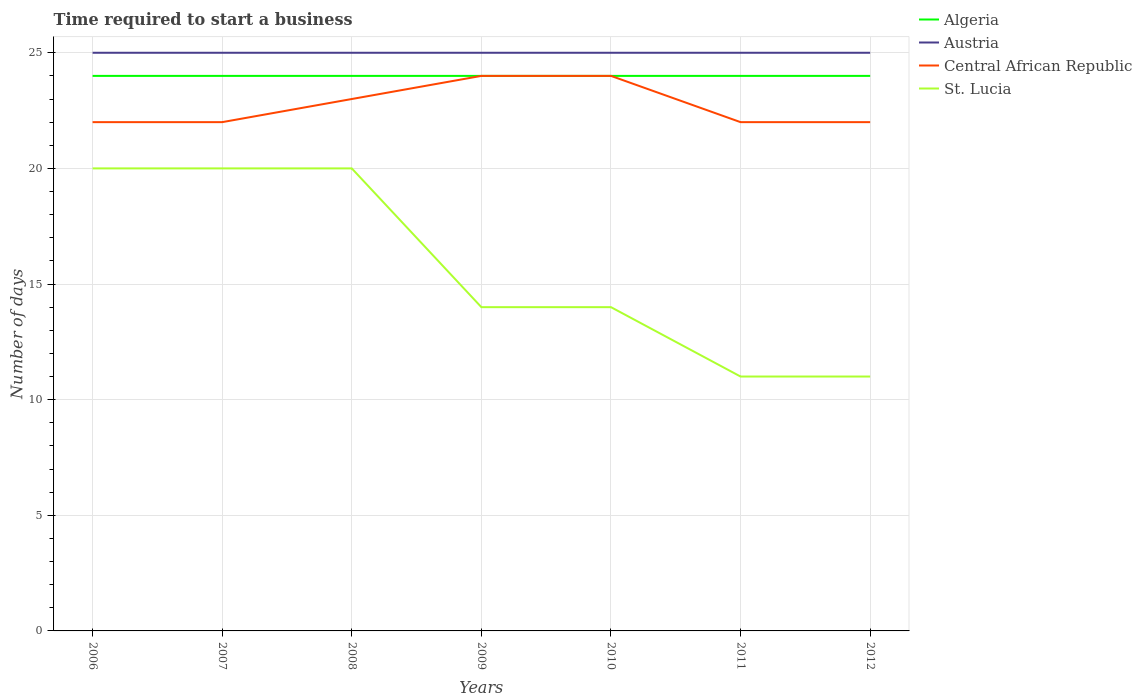How many different coloured lines are there?
Your response must be concise. 4. Does the line corresponding to Algeria intersect with the line corresponding to Central African Republic?
Your answer should be very brief. Yes. Is the number of lines equal to the number of legend labels?
Offer a very short reply. Yes. Across all years, what is the maximum number of days required to start a business in Central African Republic?
Make the answer very short. 22. In which year was the number of days required to start a business in Austria maximum?
Ensure brevity in your answer.  2006. What is the difference between the highest and the lowest number of days required to start a business in Austria?
Give a very brief answer. 0. Is the number of days required to start a business in Central African Republic strictly greater than the number of days required to start a business in Algeria over the years?
Your answer should be compact. No. How many lines are there?
Offer a very short reply. 4. Are the values on the major ticks of Y-axis written in scientific E-notation?
Provide a short and direct response. No. Does the graph contain any zero values?
Offer a very short reply. No. Does the graph contain grids?
Your response must be concise. Yes. Where does the legend appear in the graph?
Offer a terse response. Top right. How are the legend labels stacked?
Make the answer very short. Vertical. What is the title of the graph?
Provide a short and direct response. Time required to start a business. Does "Turkey" appear as one of the legend labels in the graph?
Your answer should be compact. No. What is the label or title of the Y-axis?
Make the answer very short. Number of days. What is the Number of days in Austria in 2006?
Offer a very short reply. 25. What is the Number of days in Austria in 2007?
Keep it short and to the point. 25. What is the Number of days in St. Lucia in 2007?
Keep it short and to the point. 20. What is the Number of days in Austria in 2008?
Ensure brevity in your answer.  25. What is the Number of days in Central African Republic in 2008?
Your response must be concise. 23. What is the Number of days of Algeria in 2009?
Keep it short and to the point. 24. What is the Number of days of Austria in 2009?
Offer a terse response. 25. What is the Number of days in Central African Republic in 2009?
Give a very brief answer. 24. What is the Number of days of Algeria in 2010?
Provide a succinct answer. 24. What is the Number of days of Austria in 2010?
Give a very brief answer. 25. What is the Number of days of St. Lucia in 2010?
Give a very brief answer. 14. What is the Number of days in Austria in 2011?
Offer a terse response. 25. What is the Number of days of Algeria in 2012?
Make the answer very short. 24. What is the Number of days in Central African Republic in 2012?
Give a very brief answer. 22. Across all years, what is the maximum Number of days of Algeria?
Provide a short and direct response. 24. Across all years, what is the maximum Number of days in Central African Republic?
Make the answer very short. 24. Across all years, what is the maximum Number of days in St. Lucia?
Keep it short and to the point. 20. Across all years, what is the minimum Number of days of Algeria?
Your answer should be very brief. 24. Across all years, what is the minimum Number of days in St. Lucia?
Your answer should be very brief. 11. What is the total Number of days of Algeria in the graph?
Your answer should be very brief. 168. What is the total Number of days in Austria in the graph?
Give a very brief answer. 175. What is the total Number of days in Central African Republic in the graph?
Your answer should be very brief. 159. What is the total Number of days of St. Lucia in the graph?
Your answer should be very brief. 110. What is the difference between the Number of days in Algeria in 2006 and that in 2007?
Give a very brief answer. 0. What is the difference between the Number of days of Central African Republic in 2006 and that in 2008?
Keep it short and to the point. -1. What is the difference between the Number of days of St. Lucia in 2006 and that in 2008?
Offer a very short reply. 0. What is the difference between the Number of days in Algeria in 2006 and that in 2009?
Provide a short and direct response. 0. What is the difference between the Number of days of St. Lucia in 2006 and that in 2009?
Offer a terse response. 6. What is the difference between the Number of days of Algeria in 2006 and that in 2010?
Offer a terse response. 0. What is the difference between the Number of days of Central African Republic in 2006 and that in 2010?
Keep it short and to the point. -2. What is the difference between the Number of days of Algeria in 2006 and that in 2011?
Your response must be concise. 0. What is the difference between the Number of days in Austria in 2006 and that in 2011?
Make the answer very short. 0. What is the difference between the Number of days in Central African Republic in 2006 and that in 2011?
Your response must be concise. 0. What is the difference between the Number of days in St. Lucia in 2006 and that in 2011?
Make the answer very short. 9. What is the difference between the Number of days of Algeria in 2006 and that in 2012?
Ensure brevity in your answer.  0. What is the difference between the Number of days in Central African Republic in 2006 and that in 2012?
Offer a terse response. 0. What is the difference between the Number of days in Algeria in 2007 and that in 2008?
Offer a very short reply. 0. What is the difference between the Number of days of Algeria in 2007 and that in 2009?
Give a very brief answer. 0. What is the difference between the Number of days of Central African Republic in 2007 and that in 2009?
Ensure brevity in your answer.  -2. What is the difference between the Number of days in Austria in 2007 and that in 2010?
Make the answer very short. 0. What is the difference between the Number of days in St. Lucia in 2007 and that in 2010?
Give a very brief answer. 6. What is the difference between the Number of days in Austria in 2007 and that in 2011?
Provide a succinct answer. 0. What is the difference between the Number of days of St. Lucia in 2007 and that in 2011?
Provide a short and direct response. 9. What is the difference between the Number of days in Austria in 2007 and that in 2012?
Make the answer very short. 0. What is the difference between the Number of days in Central African Republic in 2007 and that in 2012?
Provide a short and direct response. 0. What is the difference between the Number of days in Algeria in 2008 and that in 2009?
Offer a very short reply. 0. What is the difference between the Number of days in Austria in 2008 and that in 2010?
Give a very brief answer. 0. What is the difference between the Number of days of Central African Republic in 2008 and that in 2010?
Give a very brief answer. -1. What is the difference between the Number of days in Algeria in 2008 and that in 2011?
Keep it short and to the point. 0. What is the difference between the Number of days in Austria in 2008 and that in 2011?
Ensure brevity in your answer.  0. What is the difference between the Number of days of Central African Republic in 2008 and that in 2011?
Your answer should be compact. 1. What is the difference between the Number of days of St. Lucia in 2008 and that in 2011?
Make the answer very short. 9. What is the difference between the Number of days of Algeria in 2008 and that in 2012?
Your answer should be very brief. 0. What is the difference between the Number of days in Austria in 2008 and that in 2012?
Your answer should be compact. 0. What is the difference between the Number of days in Central African Republic in 2008 and that in 2012?
Ensure brevity in your answer.  1. What is the difference between the Number of days of St. Lucia in 2008 and that in 2012?
Make the answer very short. 9. What is the difference between the Number of days in Algeria in 2009 and that in 2010?
Keep it short and to the point. 0. What is the difference between the Number of days of Central African Republic in 2009 and that in 2010?
Ensure brevity in your answer.  0. What is the difference between the Number of days in St. Lucia in 2009 and that in 2010?
Offer a very short reply. 0. What is the difference between the Number of days in Algeria in 2009 and that in 2011?
Provide a succinct answer. 0. What is the difference between the Number of days in St. Lucia in 2009 and that in 2011?
Provide a succinct answer. 3. What is the difference between the Number of days of Austria in 2009 and that in 2012?
Provide a short and direct response. 0. What is the difference between the Number of days of St. Lucia in 2009 and that in 2012?
Offer a very short reply. 3. What is the difference between the Number of days of Austria in 2010 and that in 2011?
Your response must be concise. 0. What is the difference between the Number of days of St. Lucia in 2010 and that in 2011?
Provide a short and direct response. 3. What is the difference between the Number of days of Central African Republic in 2010 and that in 2012?
Offer a terse response. 2. What is the difference between the Number of days of Central African Republic in 2011 and that in 2012?
Your answer should be compact. 0. What is the difference between the Number of days of Algeria in 2006 and the Number of days of Austria in 2007?
Your response must be concise. -1. What is the difference between the Number of days of Algeria in 2006 and the Number of days of St. Lucia in 2007?
Offer a terse response. 4. What is the difference between the Number of days of Austria in 2006 and the Number of days of Central African Republic in 2007?
Keep it short and to the point. 3. What is the difference between the Number of days of Central African Republic in 2006 and the Number of days of St. Lucia in 2008?
Give a very brief answer. 2. What is the difference between the Number of days of Algeria in 2006 and the Number of days of Austria in 2009?
Keep it short and to the point. -1. What is the difference between the Number of days of Algeria in 2006 and the Number of days of Central African Republic in 2009?
Make the answer very short. 0. What is the difference between the Number of days of Algeria in 2006 and the Number of days of St. Lucia in 2009?
Give a very brief answer. 10. What is the difference between the Number of days of Austria in 2006 and the Number of days of St. Lucia in 2009?
Offer a terse response. 11. What is the difference between the Number of days of Algeria in 2006 and the Number of days of Austria in 2010?
Offer a very short reply. -1. What is the difference between the Number of days of Algeria in 2006 and the Number of days of St. Lucia in 2010?
Your answer should be very brief. 10. What is the difference between the Number of days of Algeria in 2006 and the Number of days of Austria in 2011?
Give a very brief answer. -1. What is the difference between the Number of days of Austria in 2006 and the Number of days of Central African Republic in 2011?
Give a very brief answer. 3. What is the difference between the Number of days in Algeria in 2006 and the Number of days in Central African Republic in 2012?
Make the answer very short. 2. What is the difference between the Number of days in Algeria in 2006 and the Number of days in St. Lucia in 2012?
Ensure brevity in your answer.  13. What is the difference between the Number of days of Austria in 2006 and the Number of days of Central African Republic in 2012?
Provide a succinct answer. 3. What is the difference between the Number of days in Austria in 2006 and the Number of days in St. Lucia in 2012?
Keep it short and to the point. 14. What is the difference between the Number of days of Central African Republic in 2006 and the Number of days of St. Lucia in 2012?
Offer a terse response. 11. What is the difference between the Number of days of Algeria in 2007 and the Number of days of Central African Republic in 2008?
Keep it short and to the point. 1. What is the difference between the Number of days of Algeria in 2007 and the Number of days of St. Lucia in 2008?
Make the answer very short. 4. What is the difference between the Number of days in Austria in 2007 and the Number of days in St. Lucia in 2008?
Keep it short and to the point. 5. What is the difference between the Number of days in Central African Republic in 2007 and the Number of days in St. Lucia in 2008?
Offer a very short reply. 2. What is the difference between the Number of days of Algeria in 2007 and the Number of days of Austria in 2009?
Provide a short and direct response. -1. What is the difference between the Number of days of Algeria in 2007 and the Number of days of St. Lucia in 2009?
Give a very brief answer. 10. What is the difference between the Number of days of Austria in 2007 and the Number of days of St. Lucia in 2009?
Provide a short and direct response. 11. What is the difference between the Number of days in Central African Republic in 2007 and the Number of days in St. Lucia in 2009?
Your answer should be very brief. 8. What is the difference between the Number of days in Algeria in 2007 and the Number of days in Austria in 2010?
Provide a short and direct response. -1. What is the difference between the Number of days in Algeria in 2007 and the Number of days in St. Lucia in 2010?
Your answer should be very brief. 10. What is the difference between the Number of days in Austria in 2007 and the Number of days in Central African Republic in 2010?
Keep it short and to the point. 1. What is the difference between the Number of days in Austria in 2007 and the Number of days in St. Lucia in 2010?
Your answer should be very brief. 11. What is the difference between the Number of days of Central African Republic in 2007 and the Number of days of St. Lucia in 2010?
Give a very brief answer. 8. What is the difference between the Number of days of Algeria in 2007 and the Number of days of Austria in 2011?
Your answer should be very brief. -1. What is the difference between the Number of days in Algeria in 2007 and the Number of days in Central African Republic in 2011?
Your answer should be compact. 2. What is the difference between the Number of days of Austria in 2007 and the Number of days of Central African Republic in 2011?
Give a very brief answer. 3. What is the difference between the Number of days in Austria in 2007 and the Number of days in St. Lucia in 2012?
Offer a very short reply. 14. What is the difference between the Number of days of Algeria in 2008 and the Number of days of Central African Republic in 2009?
Offer a very short reply. 0. What is the difference between the Number of days in Algeria in 2008 and the Number of days in Austria in 2010?
Make the answer very short. -1. What is the difference between the Number of days of Austria in 2008 and the Number of days of Central African Republic in 2010?
Your response must be concise. 1. What is the difference between the Number of days in Algeria in 2008 and the Number of days in Central African Republic in 2011?
Offer a very short reply. 2. What is the difference between the Number of days of Austria in 2008 and the Number of days of Central African Republic in 2011?
Provide a succinct answer. 3. What is the difference between the Number of days of Central African Republic in 2008 and the Number of days of St. Lucia in 2011?
Offer a very short reply. 12. What is the difference between the Number of days in Algeria in 2008 and the Number of days in St. Lucia in 2012?
Offer a terse response. 13. What is the difference between the Number of days in Central African Republic in 2008 and the Number of days in St. Lucia in 2012?
Keep it short and to the point. 12. What is the difference between the Number of days of Algeria in 2009 and the Number of days of Austria in 2010?
Provide a succinct answer. -1. What is the difference between the Number of days in Austria in 2009 and the Number of days in St. Lucia in 2010?
Provide a succinct answer. 11. What is the difference between the Number of days in Algeria in 2009 and the Number of days in Austria in 2011?
Your answer should be compact. -1. What is the difference between the Number of days of Algeria in 2009 and the Number of days of St. Lucia in 2011?
Give a very brief answer. 13. What is the difference between the Number of days of Austria in 2009 and the Number of days of Central African Republic in 2011?
Give a very brief answer. 3. What is the difference between the Number of days in Austria in 2009 and the Number of days in St. Lucia in 2011?
Offer a very short reply. 14. What is the difference between the Number of days of Central African Republic in 2009 and the Number of days of St. Lucia in 2011?
Give a very brief answer. 13. What is the difference between the Number of days in Austria in 2009 and the Number of days in Central African Republic in 2012?
Make the answer very short. 3. What is the difference between the Number of days of Austria in 2009 and the Number of days of St. Lucia in 2012?
Make the answer very short. 14. What is the difference between the Number of days of Central African Republic in 2009 and the Number of days of St. Lucia in 2012?
Your answer should be very brief. 13. What is the difference between the Number of days of Algeria in 2010 and the Number of days of Austria in 2011?
Offer a terse response. -1. What is the difference between the Number of days in Algeria in 2010 and the Number of days in Central African Republic in 2011?
Keep it short and to the point. 2. What is the difference between the Number of days of Austria in 2010 and the Number of days of Central African Republic in 2011?
Provide a succinct answer. 3. What is the difference between the Number of days of Austria in 2010 and the Number of days of St. Lucia in 2011?
Ensure brevity in your answer.  14. What is the difference between the Number of days in Central African Republic in 2010 and the Number of days in St. Lucia in 2011?
Your response must be concise. 13. What is the difference between the Number of days in Algeria in 2010 and the Number of days in Austria in 2012?
Make the answer very short. -1. What is the difference between the Number of days in Algeria in 2010 and the Number of days in Central African Republic in 2012?
Offer a terse response. 2. What is the difference between the Number of days of Austria in 2010 and the Number of days of Central African Republic in 2012?
Provide a succinct answer. 3. What is the difference between the Number of days in Austria in 2010 and the Number of days in St. Lucia in 2012?
Offer a terse response. 14. What is the difference between the Number of days in Algeria in 2011 and the Number of days in Austria in 2012?
Your answer should be very brief. -1. What is the difference between the Number of days in Algeria in 2011 and the Number of days in Central African Republic in 2012?
Make the answer very short. 2. What is the difference between the Number of days of Algeria in 2011 and the Number of days of St. Lucia in 2012?
Ensure brevity in your answer.  13. What is the difference between the Number of days in Austria in 2011 and the Number of days in St. Lucia in 2012?
Provide a short and direct response. 14. What is the average Number of days in Algeria per year?
Offer a very short reply. 24. What is the average Number of days in Austria per year?
Your answer should be compact. 25. What is the average Number of days in Central African Republic per year?
Make the answer very short. 22.71. What is the average Number of days of St. Lucia per year?
Ensure brevity in your answer.  15.71. In the year 2006, what is the difference between the Number of days in Algeria and Number of days in Austria?
Offer a terse response. -1. In the year 2006, what is the difference between the Number of days of Algeria and Number of days of Central African Republic?
Make the answer very short. 2. In the year 2006, what is the difference between the Number of days in Austria and Number of days in St. Lucia?
Give a very brief answer. 5. In the year 2006, what is the difference between the Number of days in Central African Republic and Number of days in St. Lucia?
Give a very brief answer. 2. In the year 2007, what is the difference between the Number of days in Algeria and Number of days in Austria?
Provide a succinct answer. -1. In the year 2007, what is the difference between the Number of days in Algeria and Number of days in Central African Republic?
Ensure brevity in your answer.  2. In the year 2007, what is the difference between the Number of days in Central African Republic and Number of days in St. Lucia?
Provide a succinct answer. 2. In the year 2008, what is the difference between the Number of days in Austria and Number of days in Central African Republic?
Provide a short and direct response. 2. In the year 2009, what is the difference between the Number of days of Algeria and Number of days of Central African Republic?
Provide a succinct answer. 0. In the year 2009, what is the difference between the Number of days of Algeria and Number of days of St. Lucia?
Keep it short and to the point. 10. In the year 2009, what is the difference between the Number of days in Austria and Number of days in Central African Republic?
Offer a very short reply. 1. In the year 2009, what is the difference between the Number of days in Austria and Number of days in St. Lucia?
Give a very brief answer. 11. In the year 2009, what is the difference between the Number of days in Central African Republic and Number of days in St. Lucia?
Give a very brief answer. 10. In the year 2010, what is the difference between the Number of days in Algeria and Number of days in Central African Republic?
Ensure brevity in your answer.  0. In the year 2010, what is the difference between the Number of days of Algeria and Number of days of St. Lucia?
Make the answer very short. 10. In the year 2010, what is the difference between the Number of days of Austria and Number of days of Central African Republic?
Ensure brevity in your answer.  1. In the year 2010, what is the difference between the Number of days of Austria and Number of days of St. Lucia?
Your response must be concise. 11. In the year 2010, what is the difference between the Number of days in Central African Republic and Number of days in St. Lucia?
Provide a succinct answer. 10. In the year 2011, what is the difference between the Number of days in Algeria and Number of days in Austria?
Your response must be concise. -1. In the year 2011, what is the difference between the Number of days in Algeria and Number of days in Central African Republic?
Offer a terse response. 2. In the year 2011, what is the difference between the Number of days in Algeria and Number of days in St. Lucia?
Offer a terse response. 13. In the year 2011, what is the difference between the Number of days of Austria and Number of days of St. Lucia?
Ensure brevity in your answer.  14. In the year 2012, what is the difference between the Number of days of Algeria and Number of days of Austria?
Provide a succinct answer. -1. In the year 2012, what is the difference between the Number of days in Algeria and Number of days in Central African Republic?
Provide a short and direct response. 2. What is the ratio of the Number of days in Austria in 2006 to that in 2007?
Ensure brevity in your answer.  1. What is the ratio of the Number of days of Austria in 2006 to that in 2008?
Offer a terse response. 1. What is the ratio of the Number of days of Central African Republic in 2006 to that in 2008?
Provide a short and direct response. 0.96. What is the ratio of the Number of days in Algeria in 2006 to that in 2009?
Offer a terse response. 1. What is the ratio of the Number of days in Central African Republic in 2006 to that in 2009?
Give a very brief answer. 0.92. What is the ratio of the Number of days in St. Lucia in 2006 to that in 2009?
Offer a very short reply. 1.43. What is the ratio of the Number of days in Austria in 2006 to that in 2010?
Make the answer very short. 1. What is the ratio of the Number of days of Central African Republic in 2006 to that in 2010?
Your response must be concise. 0.92. What is the ratio of the Number of days in St. Lucia in 2006 to that in 2010?
Offer a very short reply. 1.43. What is the ratio of the Number of days of St. Lucia in 2006 to that in 2011?
Your answer should be compact. 1.82. What is the ratio of the Number of days in Algeria in 2006 to that in 2012?
Offer a terse response. 1. What is the ratio of the Number of days of Austria in 2006 to that in 2012?
Your answer should be compact. 1. What is the ratio of the Number of days in Central African Republic in 2006 to that in 2012?
Provide a short and direct response. 1. What is the ratio of the Number of days of St. Lucia in 2006 to that in 2012?
Keep it short and to the point. 1.82. What is the ratio of the Number of days of Austria in 2007 to that in 2008?
Ensure brevity in your answer.  1. What is the ratio of the Number of days of Central African Republic in 2007 to that in 2008?
Provide a short and direct response. 0.96. What is the ratio of the Number of days in St. Lucia in 2007 to that in 2008?
Offer a terse response. 1. What is the ratio of the Number of days in Algeria in 2007 to that in 2009?
Offer a very short reply. 1. What is the ratio of the Number of days of Austria in 2007 to that in 2009?
Your answer should be very brief. 1. What is the ratio of the Number of days of St. Lucia in 2007 to that in 2009?
Make the answer very short. 1.43. What is the ratio of the Number of days of Central African Republic in 2007 to that in 2010?
Make the answer very short. 0.92. What is the ratio of the Number of days of St. Lucia in 2007 to that in 2010?
Offer a terse response. 1.43. What is the ratio of the Number of days in Algeria in 2007 to that in 2011?
Your response must be concise. 1. What is the ratio of the Number of days in Austria in 2007 to that in 2011?
Offer a terse response. 1. What is the ratio of the Number of days in St. Lucia in 2007 to that in 2011?
Your answer should be compact. 1.82. What is the ratio of the Number of days in St. Lucia in 2007 to that in 2012?
Make the answer very short. 1.82. What is the ratio of the Number of days in Austria in 2008 to that in 2009?
Provide a succinct answer. 1. What is the ratio of the Number of days in Central African Republic in 2008 to that in 2009?
Provide a short and direct response. 0.96. What is the ratio of the Number of days in St. Lucia in 2008 to that in 2009?
Your response must be concise. 1.43. What is the ratio of the Number of days of Austria in 2008 to that in 2010?
Your answer should be compact. 1. What is the ratio of the Number of days in St. Lucia in 2008 to that in 2010?
Keep it short and to the point. 1.43. What is the ratio of the Number of days in Austria in 2008 to that in 2011?
Ensure brevity in your answer.  1. What is the ratio of the Number of days in Central African Republic in 2008 to that in 2011?
Your answer should be very brief. 1.05. What is the ratio of the Number of days of St. Lucia in 2008 to that in 2011?
Provide a succinct answer. 1.82. What is the ratio of the Number of days of Algeria in 2008 to that in 2012?
Offer a very short reply. 1. What is the ratio of the Number of days of Central African Republic in 2008 to that in 2012?
Your answer should be very brief. 1.05. What is the ratio of the Number of days in St. Lucia in 2008 to that in 2012?
Ensure brevity in your answer.  1.82. What is the ratio of the Number of days in Algeria in 2009 to that in 2010?
Your answer should be very brief. 1. What is the ratio of the Number of days in Central African Republic in 2009 to that in 2011?
Offer a terse response. 1.09. What is the ratio of the Number of days of St. Lucia in 2009 to that in 2011?
Ensure brevity in your answer.  1.27. What is the ratio of the Number of days in Austria in 2009 to that in 2012?
Provide a succinct answer. 1. What is the ratio of the Number of days of St. Lucia in 2009 to that in 2012?
Give a very brief answer. 1.27. What is the ratio of the Number of days of Austria in 2010 to that in 2011?
Keep it short and to the point. 1. What is the ratio of the Number of days in St. Lucia in 2010 to that in 2011?
Your response must be concise. 1.27. What is the ratio of the Number of days of Central African Republic in 2010 to that in 2012?
Provide a succinct answer. 1.09. What is the ratio of the Number of days of St. Lucia in 2010 to that in 2012?
Make the answer very short. 1.27. What is the ratio of the Number of days of Algeria in 2011 to that in 2012?
Your answer should be very brief. 1. What is the ratio of the Number of days of Central African Republic in 2011 to that in 2012?
Make the answer very short. 1. What is the difference between the highest and the second highest Number of days in Austria?
Provide a succinct answer. 0. What is the difference between the highest and the second highest Number of days in St. Lucia?
Make the answer very short. 0. What is the difference between the highest and the lowest Number of days of Algeria?
Give a very brief answer. 0. What is the difference between the highest and the lowest Number of days in St. Lucia?
Provide a succinct answer. 9. 